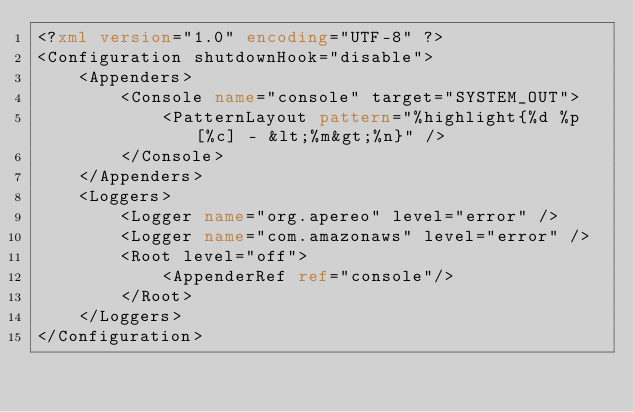<code> <loc_0><loc_0><loc_500><loc_500><_XML_><?xml version="1.0" encoding="UTF-8" ?>
<Configuration shutdownHook="disable">
    <Appenders>
        <Console name="console" target="SYSTEM_OUT">
            <PatternLayout pattern="%highlight{%d %p [%c] - &lt;%m&gt;%n}" />
        </Console>
    </Appenders>
    <Loggers>
        <Logger name="org.apereo" level="error" />
        <Logger name="com.amazonaws" level="error" />
        <Root level="off">
            <AppenderRef ref="console"/>
        </Root>
    </Loggers>
</Configuration>
</code> 